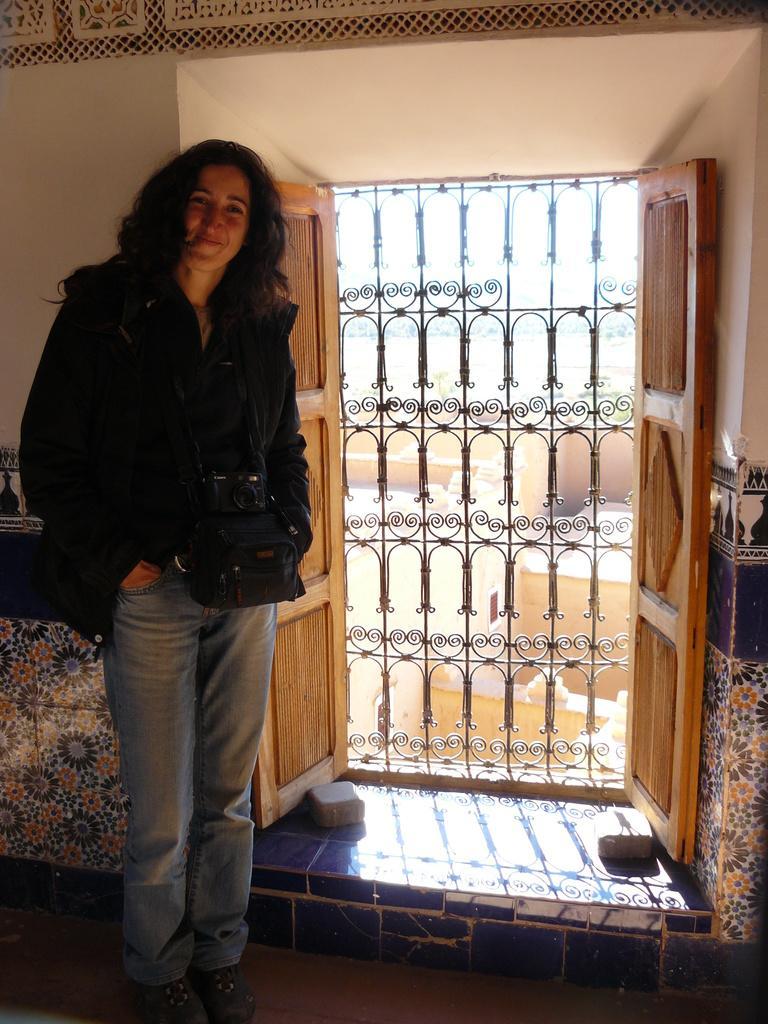Can you describe this image briefly? There is a woman wearing camera and a bag is standing and smiling. In the back there are doors, door grill and wall. 